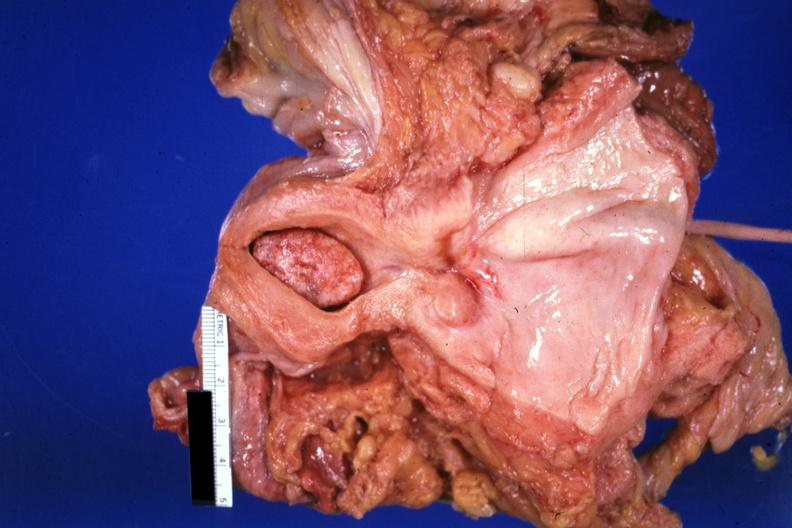what is present?
Answer the question using a single word or phrase. Female reproductive 